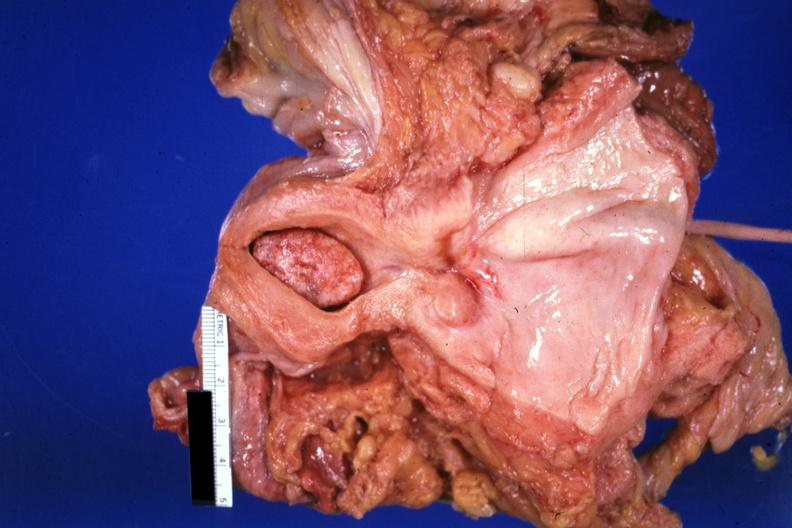what is present?
Answer the question using a single word or phrase. Female reproductive 